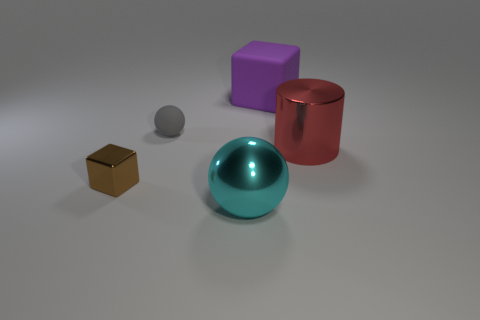Add 4 small yellow metallic cylinders. How many objects exist? 9 Subtract all balls. How many objects are left? 3 Subtract all big brown matte cylinders. Subtract all brown metallic objects. How many objects are left? 4 Add 5 cylinders. How many cylinders are left? 6 Add 5 tiny matte cylinders. How many tiny matte cylinders exist? 5 Subtract 0 brown cylinders. How many objects are left? 5 